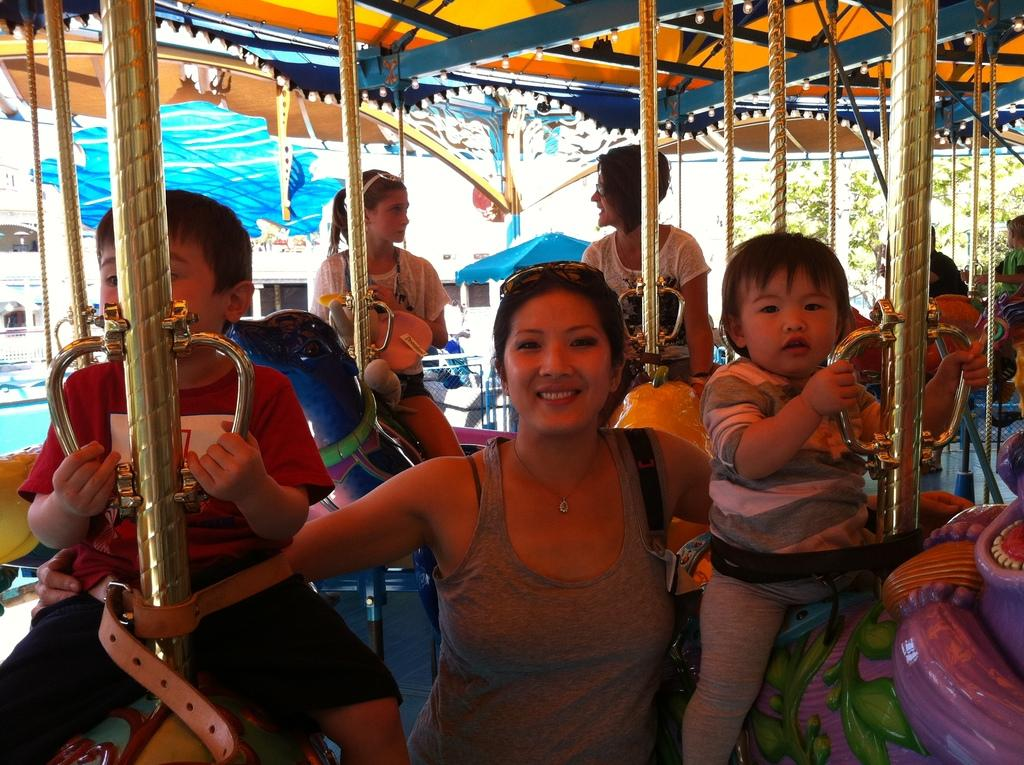Who is present in the image? There is a woman in the image. What is the woman doing? The woman is smiling. Who else is present in the image? There are children in the image. What are the children doing? The children are sitting on play equipment. What can be seen on the right side of the image? There are trees on the right side of the image. What grade is the house in the image? There is no house present in the image, so it is not possible to determine its grade. 